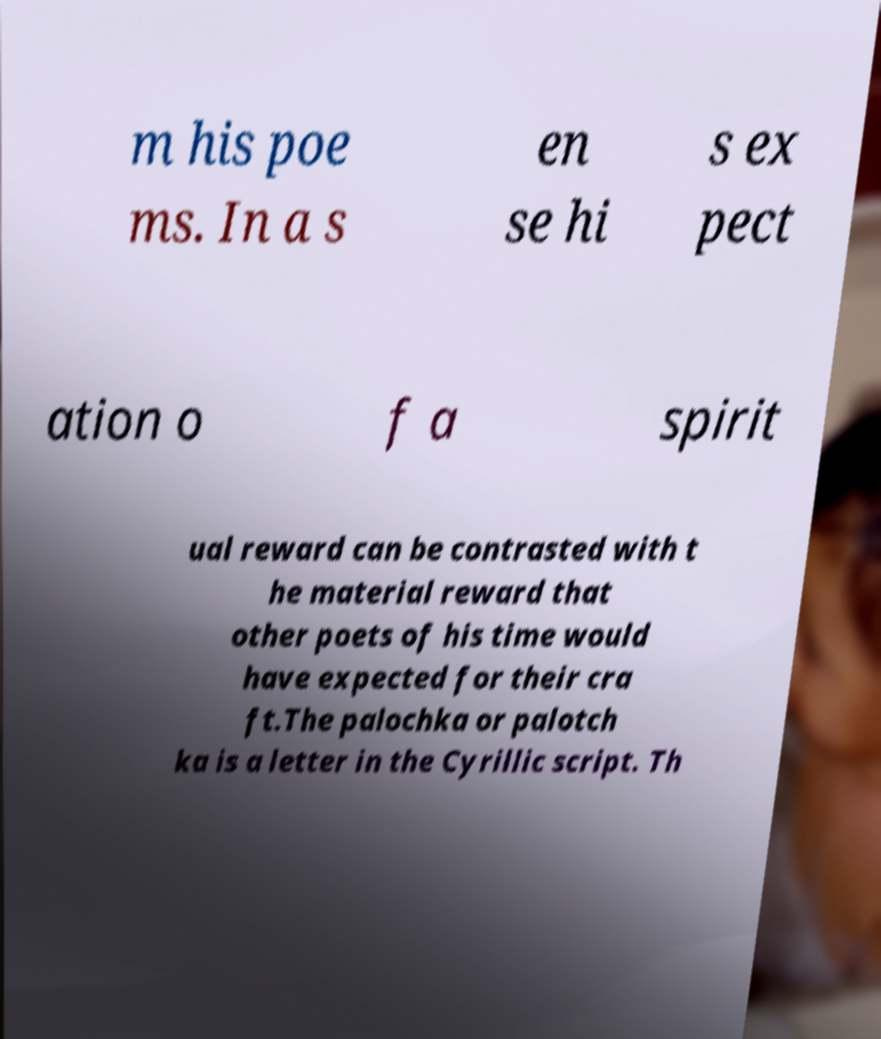Can you read and provide the text displayed in the image?This photo seems to have some interesting text. Can you extract and type it out for me? m his poe ms. In a s en se hi s ex pect ation o f a spirit ual reward can be contrasted with t he material reward that other poets of his time would have expected for their cra ft.The palochka or palotch ka is a letter in the Cyrillic script. Th 